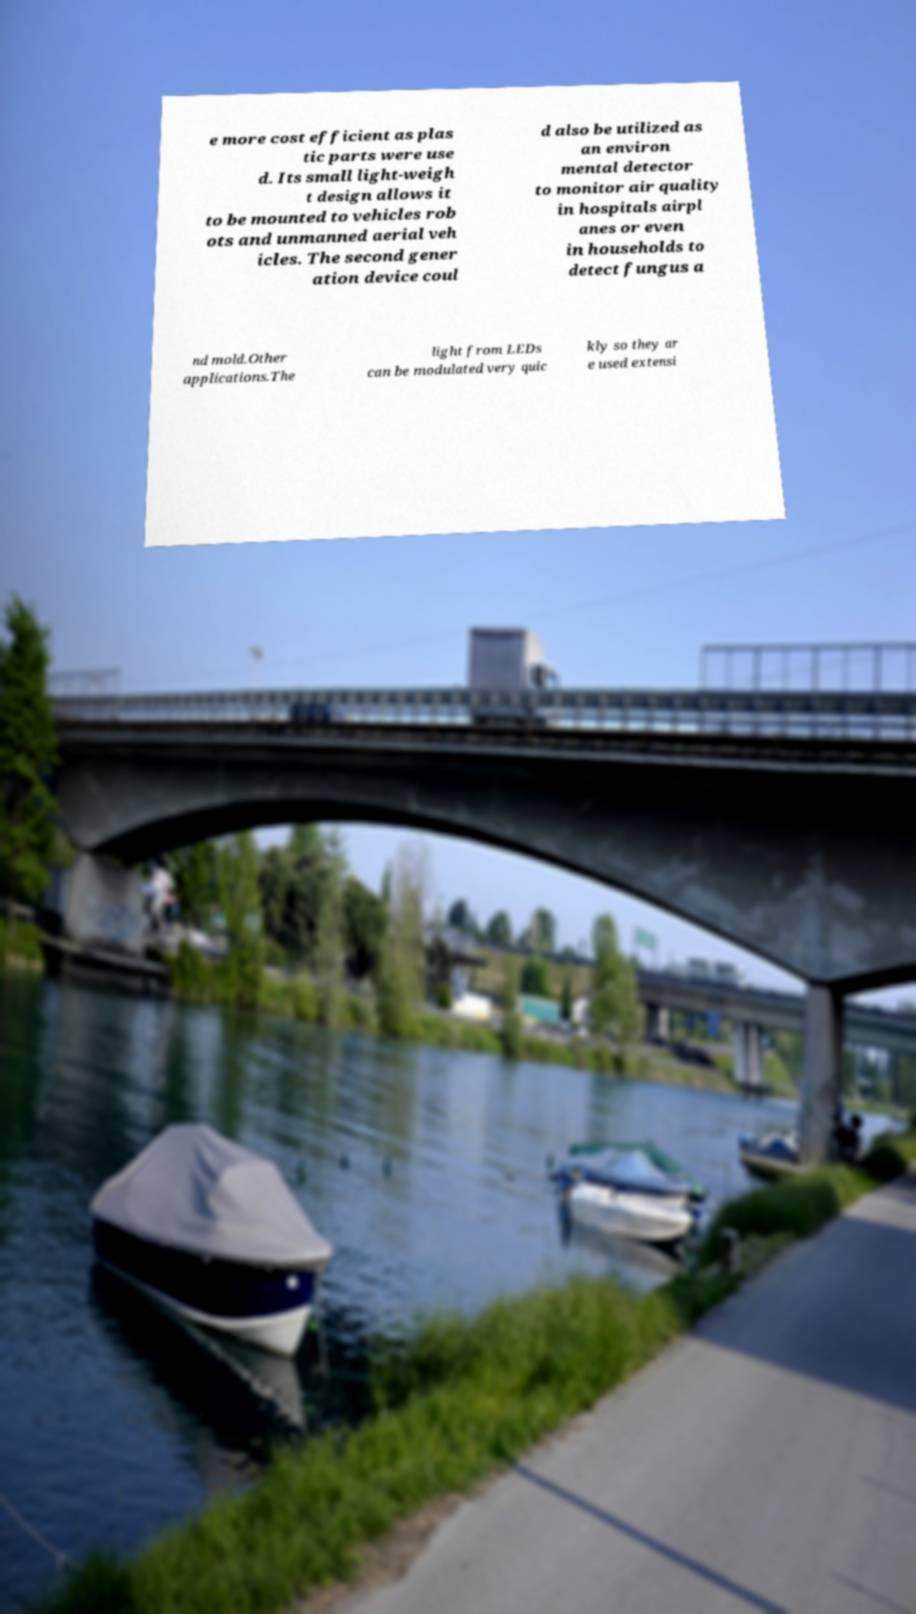Please identify and transcribe the text found in this image. e more cost efficient as plas tic parts were use d. Its small light-weigh t design allows it to be mounted to vehicles rob ots and unmanned aerial veh icles. The second gener ation device coul d also be utilized as an environ mental detector to monitor air quality in hospitals airpl anes or even in households to detect fungus a nd mold.Other applications.The light from LEDs can be modulated very quic kly so they ar e used extensi 